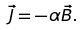Convert formula to latex. <formula><loc_0><loc_0><loc_500><loc_500>\vec { J } = - \alpha \vec { B } .</formula> 